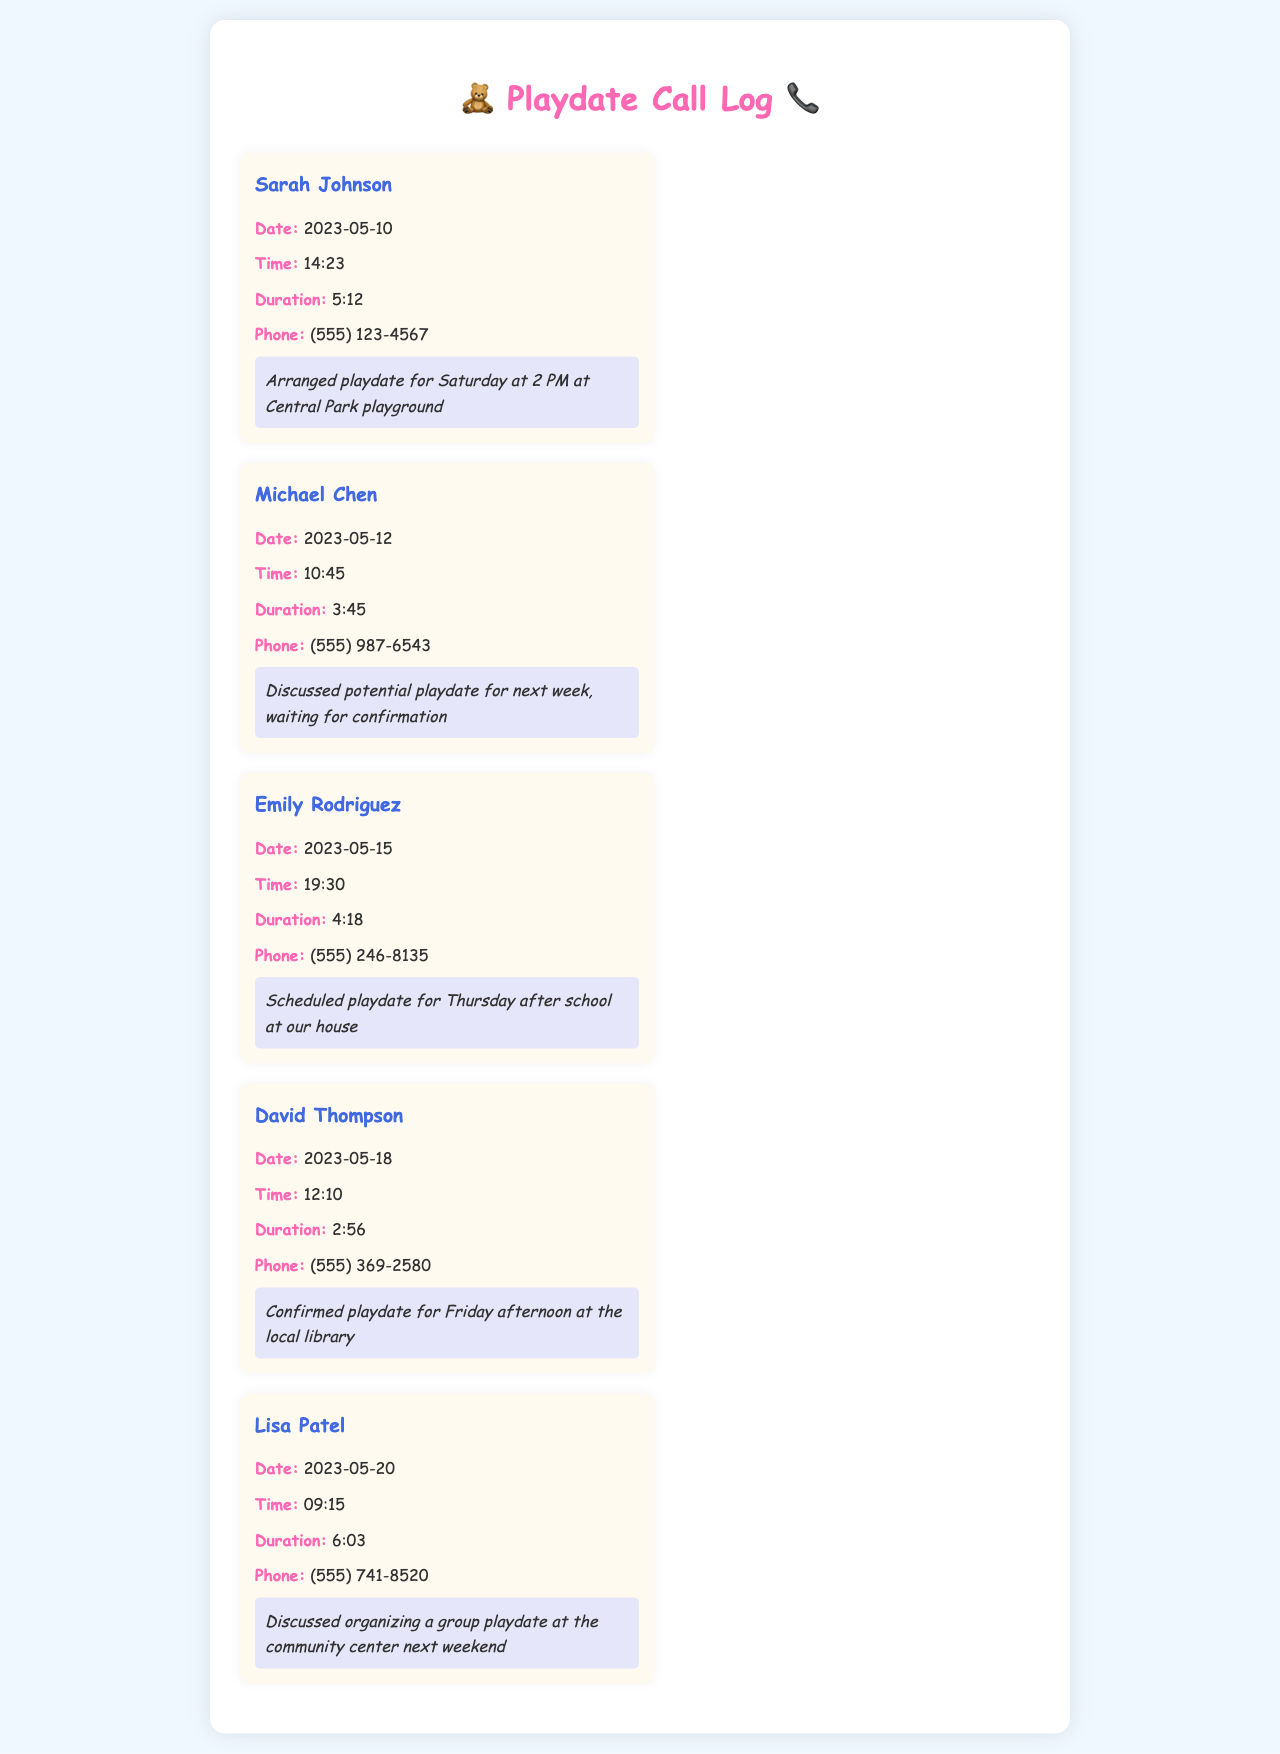what is the name of the first parent listed? The first parent listed in the call log is Sarah Johnson.
Answer: Sarah Johnson what was the duration of the call with Michael Chen? The duration of the call with Michael Chen is noted as 3 minutes and 45 seconds.
Answer: 3:45 on what date is the playdate with Emily Rodriguez scheduled? The playdate with Emily Rodriguez is scheduled for Thursday, which is inferred from the date of the call on May 15.
Answer: Thursday how many parents were contacted to arrange playdates? The document lists a total of five parents contacted for arranging playdates.
Answer: Five what location was confirmed for the playdate with David Thompson? The location confirmed for the playdate with David Thompson is the local library.
Answer: local library what time is the playdate arranged at Central Park? The time for the playdate at Central Park is arranged for 2 PM.
Answer: 2 PM who discussed organizing a group playdate at the community center? The parent who discussed this is Lisa Patel.
Answer: Lisa Patel which parent had the longest call duration? The parent with the longest call duration is Lisa Patel, with a duration of 6 minutes and 3 seconds.
Answer: 6:03 